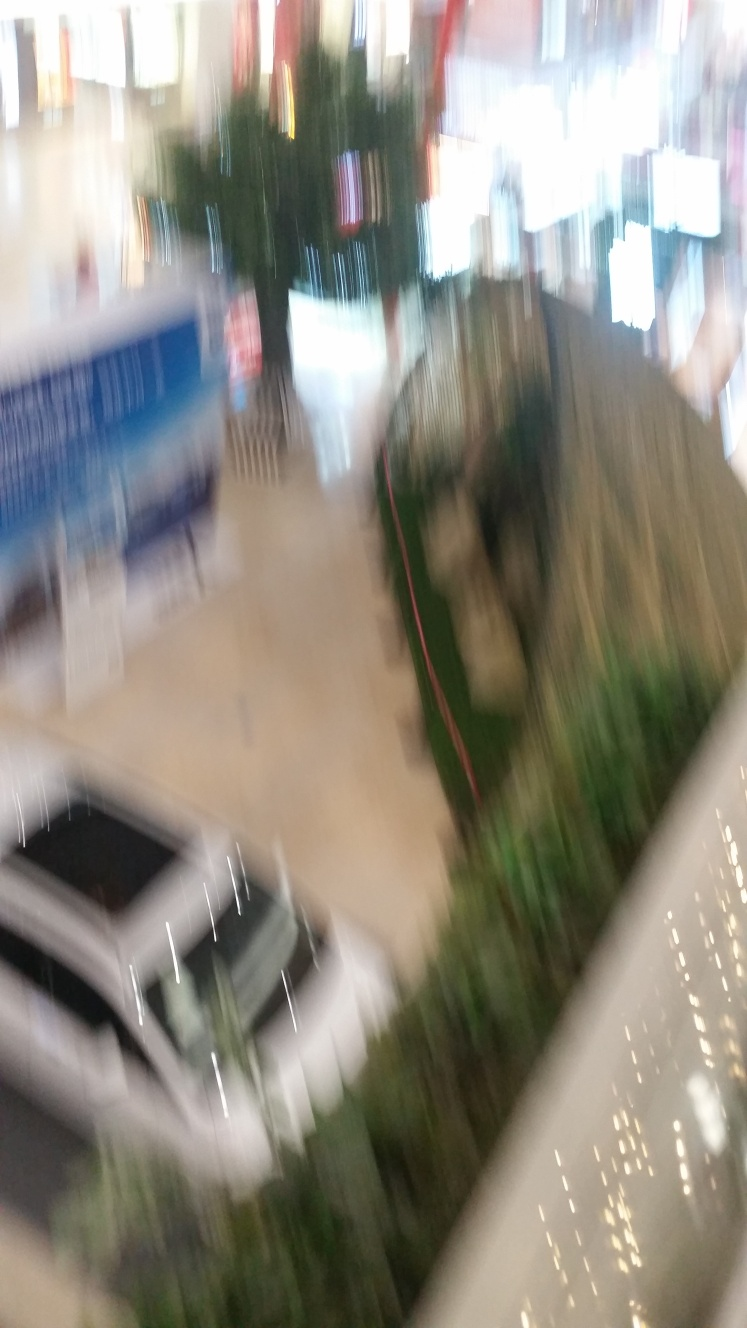Is the image of poor quality?
A. Yes
B. No
Answer with the option's letter from the given choices directly.
 A. 